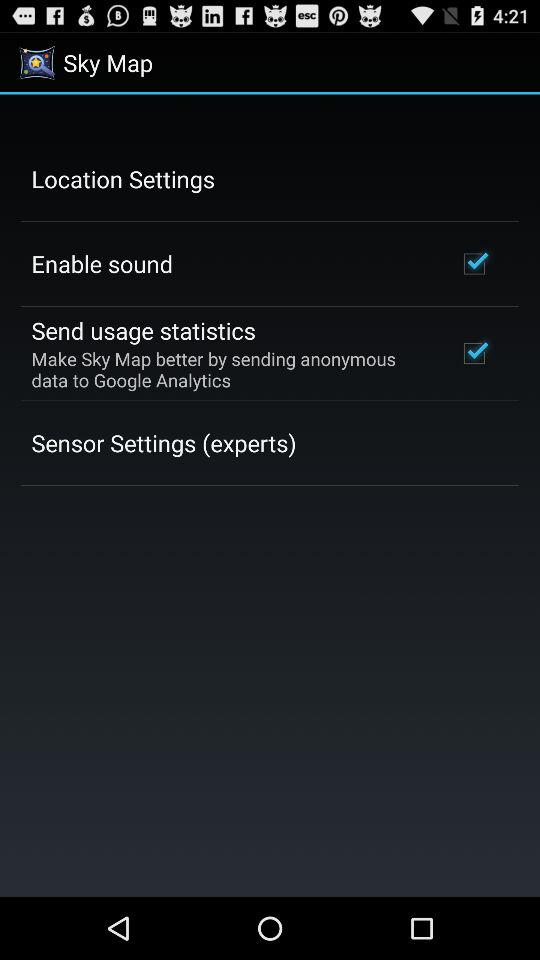What is the status of "Enable sound"? The status is "on". 